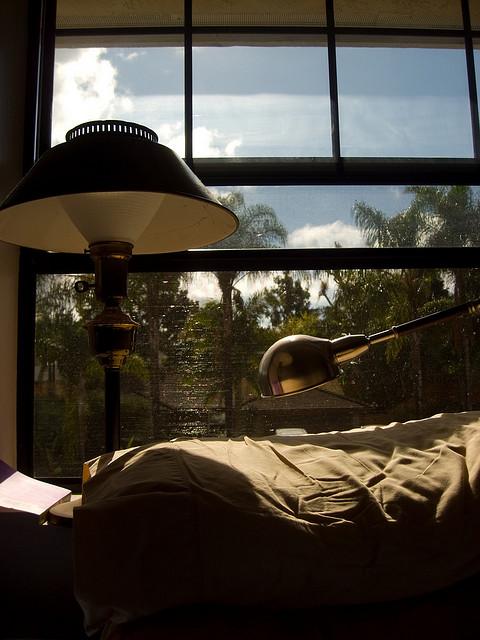How many lamps are visible in the photo?
Quick response, please. 2. Is the lamps turned on?
Quick response, please. No. What kind of trees outside?
Quick response, please. Palm. 